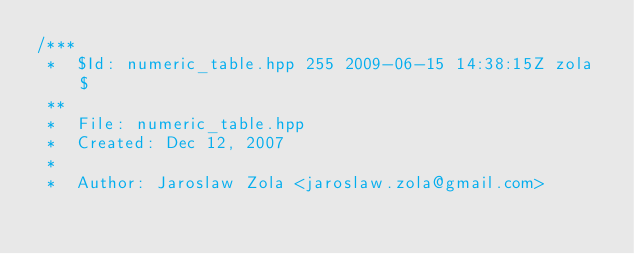Convert code to text. <code><loc_0><loc_0><loc_500><loc_500><_C++_>/***
 *  $Id: numeric_table.hpp 255 2009-06-15 14:38:15Z zola $
 **
 *  File: numeric_table.hpp
 *  Created: Dec 12, 2007
 *
 *  Author: Jaroslaw Zola <jaroslaw.zola@gmail.com></code> 